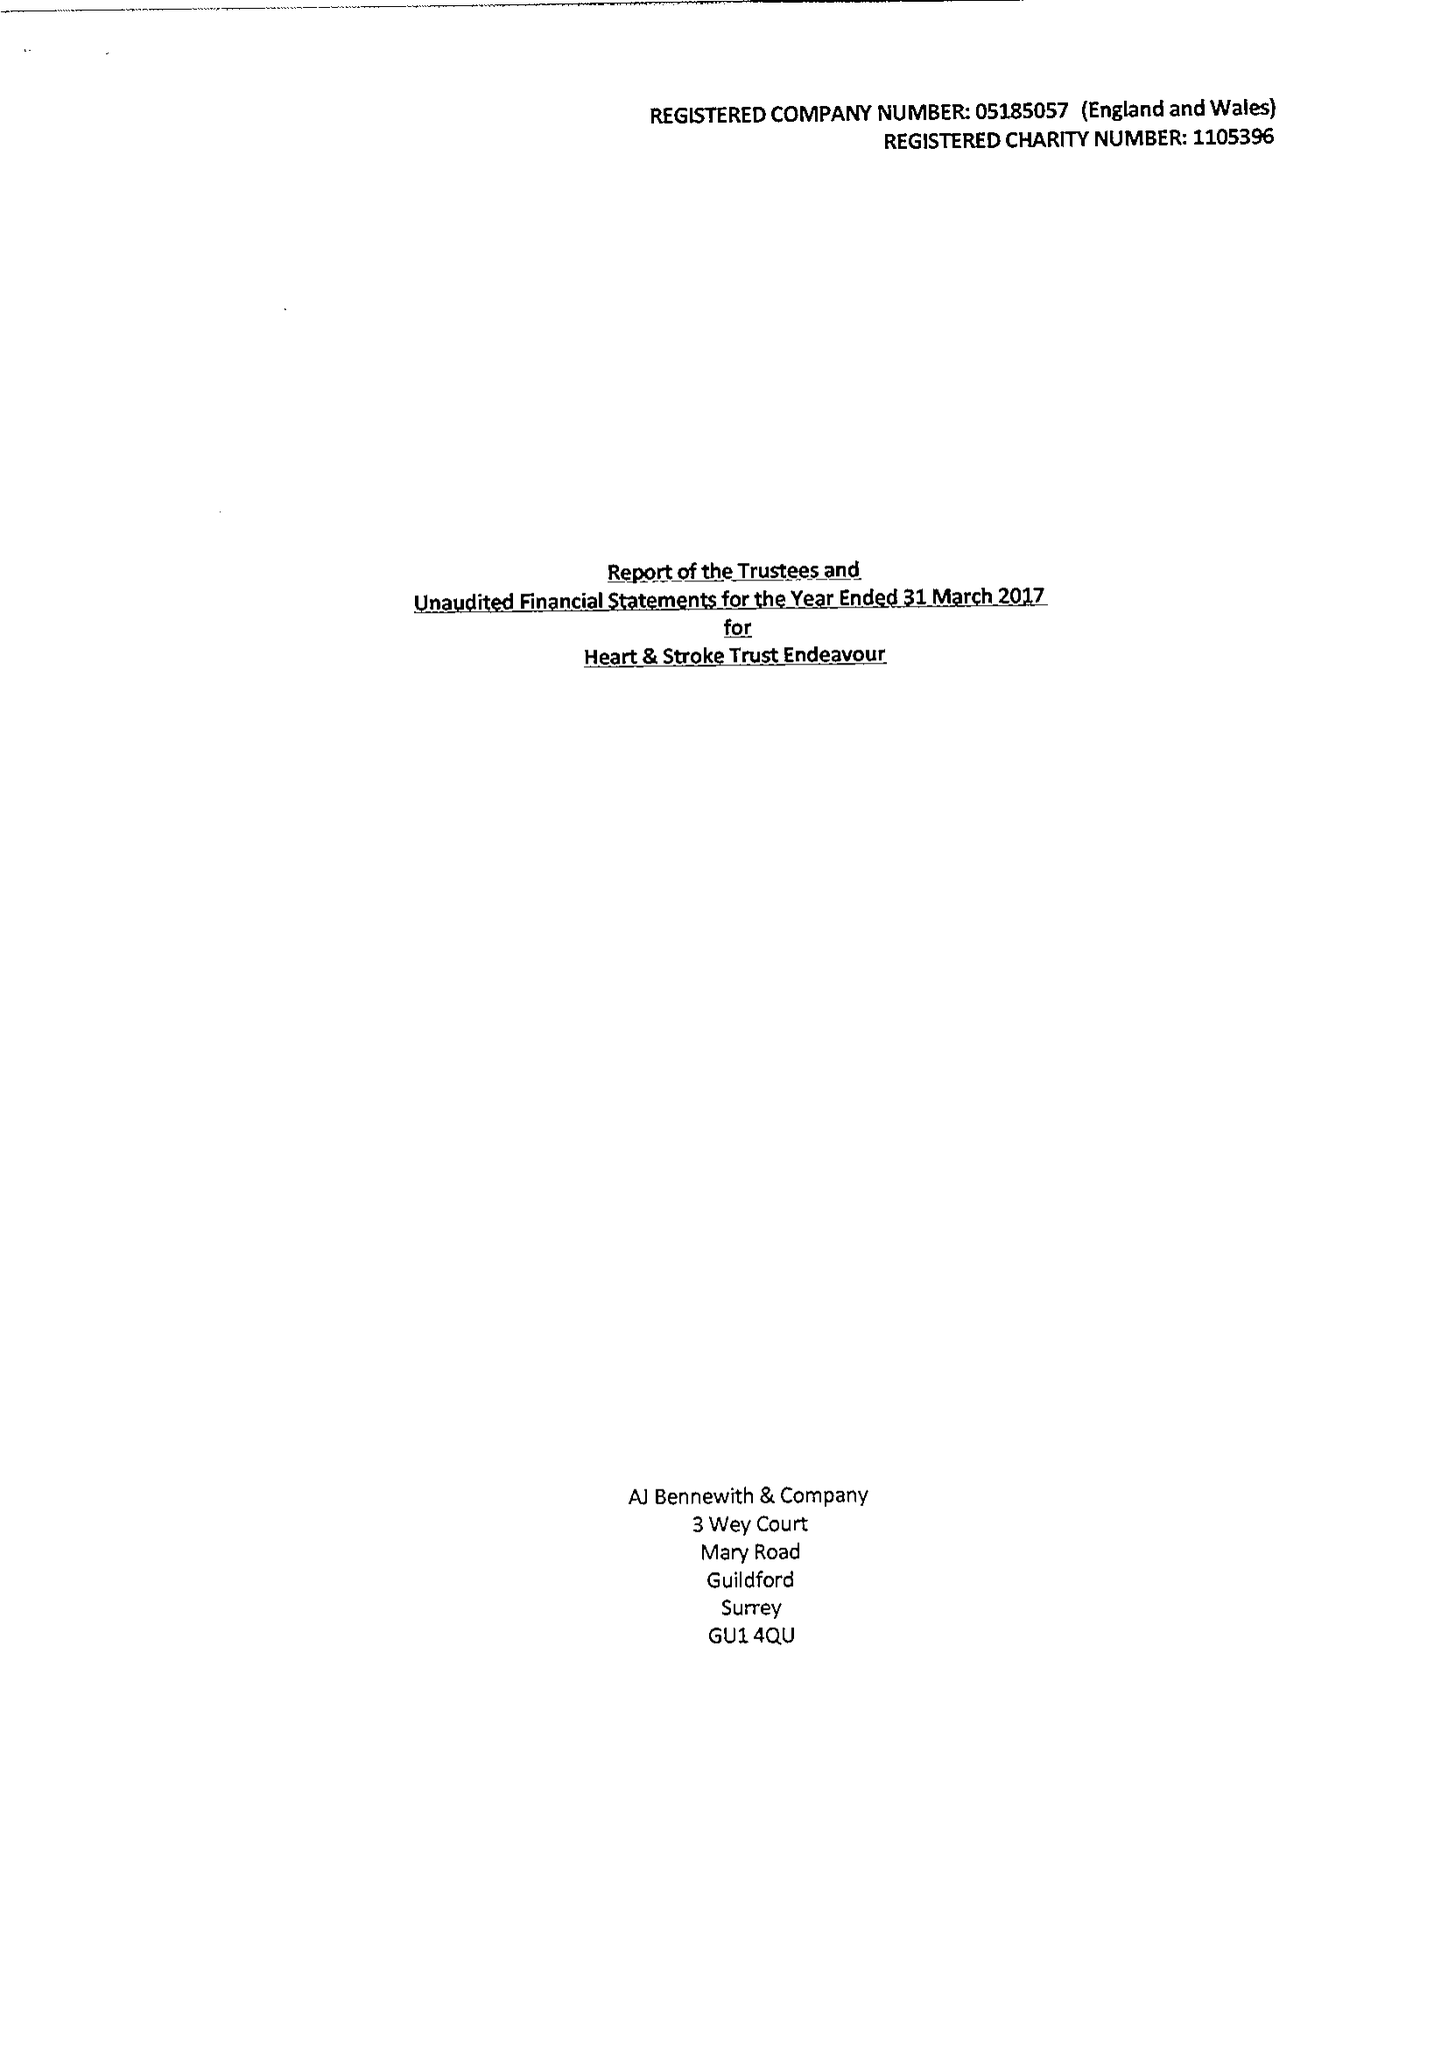What is the value for the charity_name?
Answer the question using a single word or phrase. Heart and Stroke Trust Endeavour 